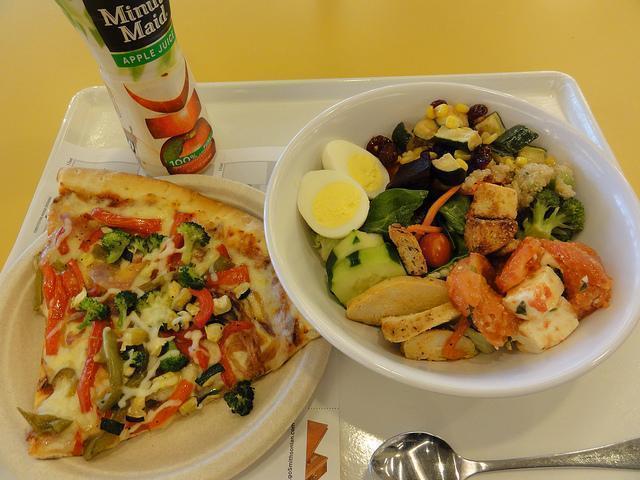What type of red sliced topping is on the pizza?
Select the accurate answer and provide justification: `Answer: choice
Rationale: srationale.`
Options: Pepper, olive, pepperoni, mushroom. Answer: pepper.
Rationale: The slices are light red like bell pepper. 